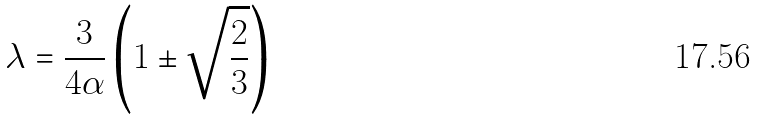<formula> <loc_0><loc_0><loc_500><loc_500>\lambda = \frac { 3 } { 4 \alpha } \left ( 1 \pm \sqrt { \frac { 2 } { 3 } } \right )</formula> 